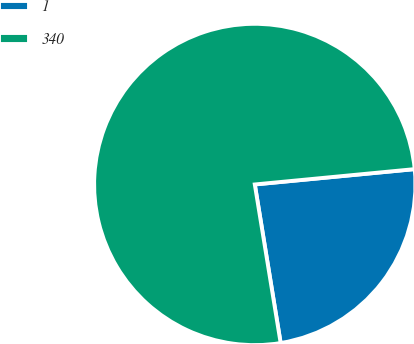Convert chart to OTSL. <chart><loc_0><loc_0><loc_500><loc_500><pie_chart><fcel>1<fcel>340<nl><fcel>23.95%<fcel>76.05%<nl></chart> 